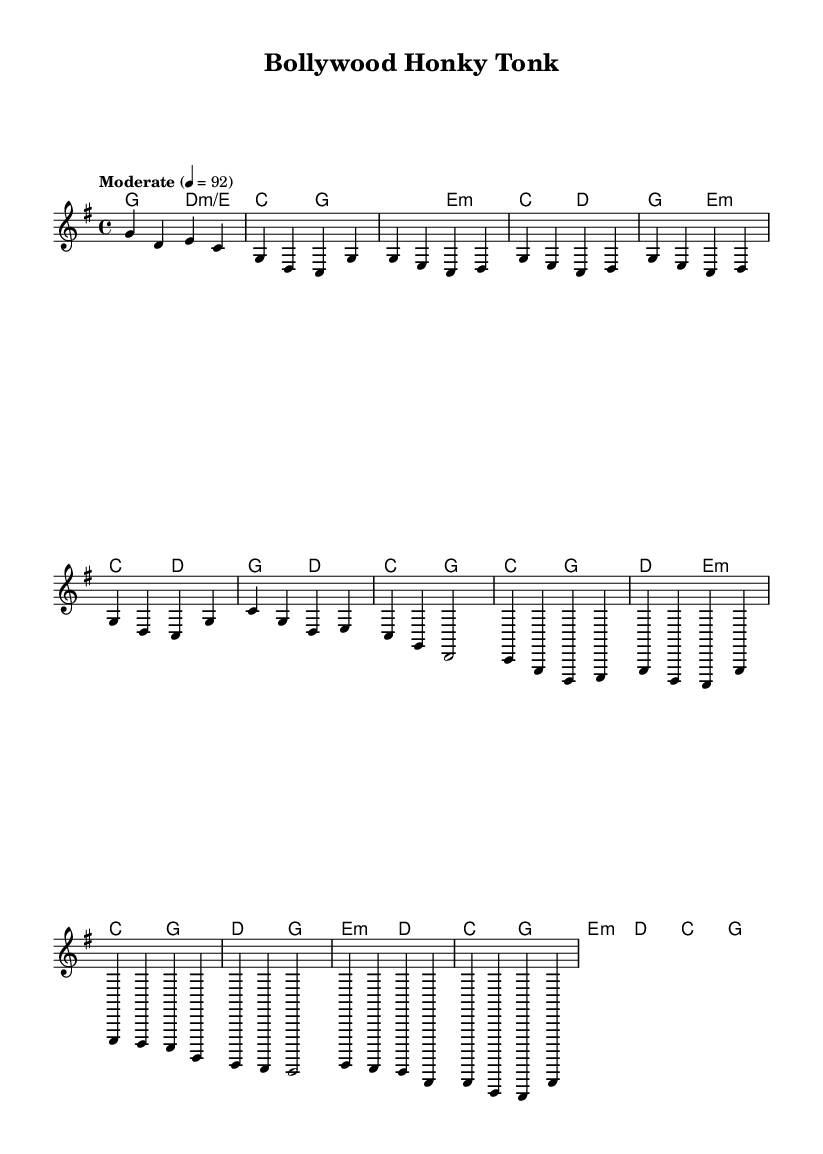What is the key signature of this music? The key signature is G major, which has one sharp (F#). This is indicated at the beginning of the sheet music.
Answer: G major What is the time signature of this piece? The time signature shown is 4/4, which means there are four beats per measure and the quarter note gets one beat. This is found at the beginning part of the score.
Answer: 4/4 What is the tempo marking for this piece? The tempo marking is "Moderate," set at 92 beats per minute. This indicates the speed at which the piece should be played and is explicitly mentioned with a specific metronome value.
Answer: Moderate How many measures are in the chorus section? The chorus section consists of four measures as indicated by the different groupings of notes. Each group represents a measure, and by counting them, we find four total.
Answer: 4 What are the two chords used in the bridge? The bridge uses the chords E minor and D major. These are specified in the harmonies section, where the respective measures show these chord names as part of the harmonic structure.
Answer: E minor, D major Which instrument is primarily featured in this section? The primary instrument is the voice, indicated by the staff labeled "main." This is where the melody is sung, while the chord names are provided separately.
Answer: Voice What is the last note of the melody? The last note of the melody is G, which can be identified by tracing the melody line to its endpoint in the final measure. It is the highest note before the piece concludes.
Answer: G 